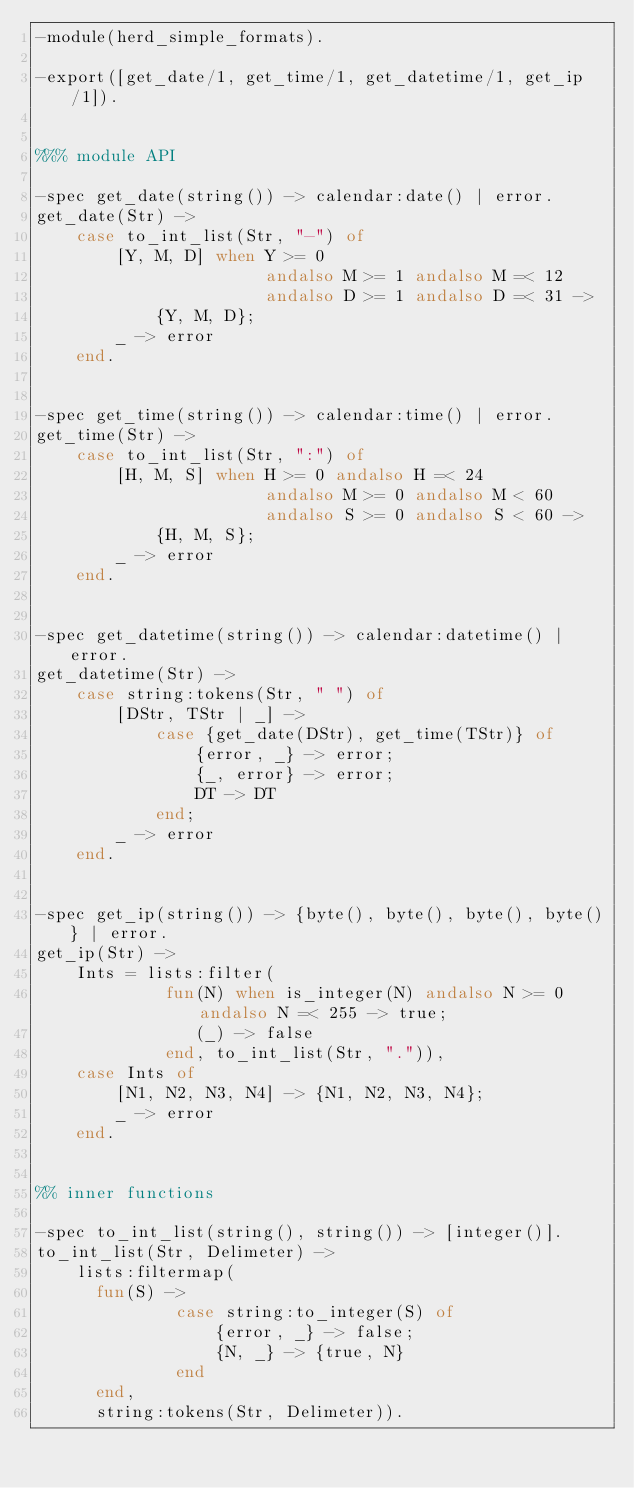Convert code to text. <code><loc_0><loc_0><loc_500><loc_500><_Erlang_>-module(herd_simple_formats).

-export([get_date/1, get_time/1, get_datetime/1, get_ip/1]).


%%% module API

-spec get_date(string()) -> calendar:date() | error.
get_date(Str) ->
    case to_int_list(Str, "-") of
        [Y, M, D] when Y >= 0
                       andalso M >= 1 andalso M =< 12
                       andalso D >= 1 andalso D =< 31 ->
            {Y, M, D};
        _ -> error
    end.


-spec get_time(string()) -> calendar:time() | error.
get_time(Str) ->
    case to_int_list(Str, ":") of
        [H, M, S] when H >= 0 andalso H =< 24
                       andalso M >= 0 andalso M < 60
                       andalso S >= 0 andalso S < 60 ->
            {H, M, S};
        _ -> error
    end.


-spec get_datetime(string()) -> calendar:datetime() | error.
get_datetime(Str) ->
    case string:tokens(Str, " ") of
        [DStr, TStr | _] ->
            case {get_date(DStr), get_time(TStr)} of
                {error, _} -> error;
                {_, error} -> error;
                DT -> DT
            end;
        _ -> error
    end.


-spec get_ip(string()) -> {byte(), byte(), byte(), byte()} | error.
get_ip(Str) ->
    Ints = lists:filter(
             fun(N) when is_integer(N) andalso N >= 0 andalso N =< 255 -> true;
                (_) -> false
             end, to_int_list(Str, ".")),
    case Ints of
        [N1, N2, N3, N4] -> {N1, N2, N3, N4};
        _ -> error
    end.


%% inner functions

-spec to_int_list(string(), string()) -> [integer()].
to_int_list(Str, Delimeter) ->
    lists:filtermap(
      fun(S) ->
              case string:to_integer(S) of
                  {error, _} -> false;
                  {N, _} -> {true, N}
              end
      end,
      string:tokens(Str, Delimeter)).
</code> 